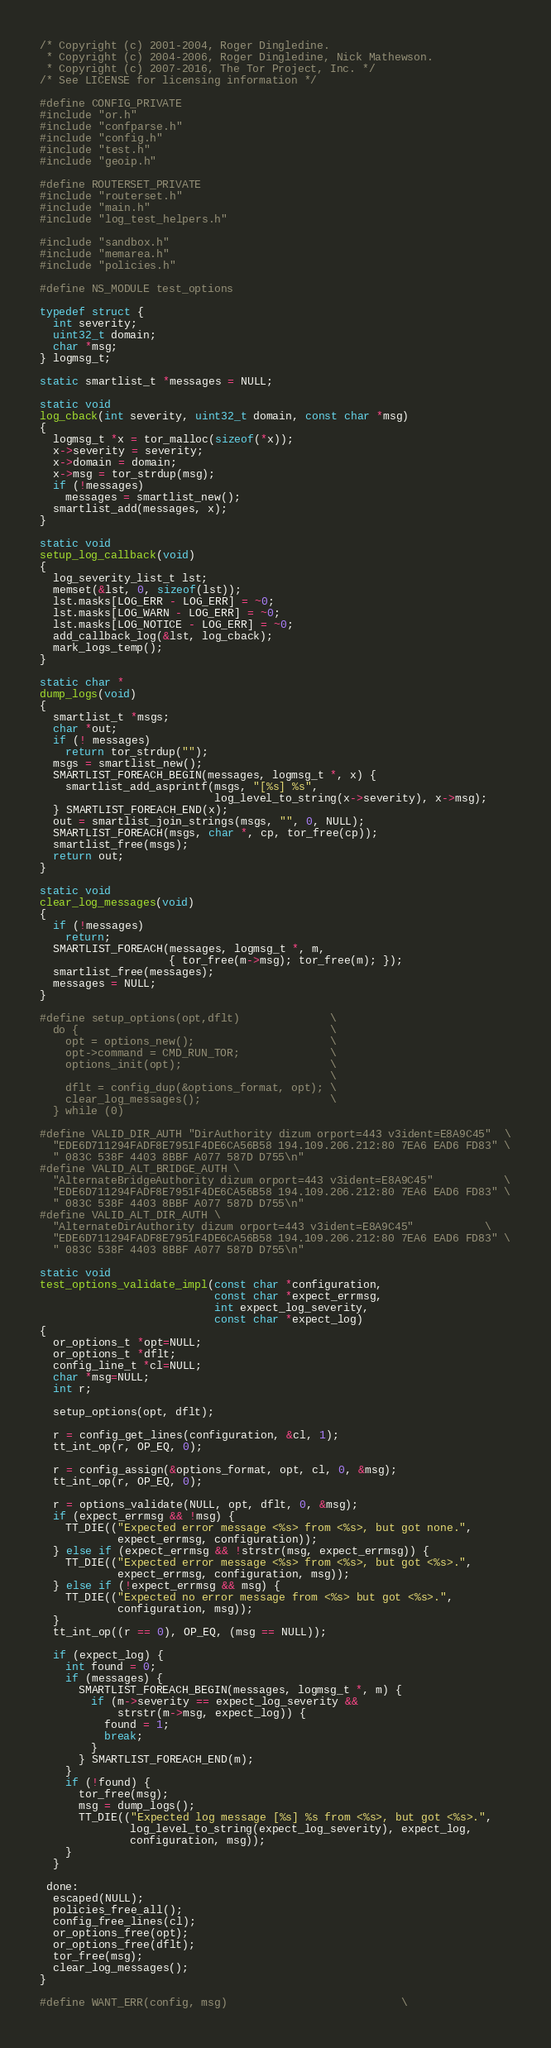Convert code to text. <code><loc_0><loc_0><loc_500><loc_500><_C_>/* Copyright (c) 2001-2004, Roger Dingledine.
 * Copyright (c) 2004-2006, Roger Dingledine, Nick Mathewson.
 * Copyright (c) 2007-2016, The Tor Project, Inc. */
/* See LICENSE for licensing information */

#define CONFIG_PRIVATE
#include "or.h"
#include "confparse.h"
#include "config.h"
#include "test.h"
#include "geoip.h"

#define ROUTERSET_PRIVATE
#include "routerset.h"
#include "main.h"
#include "log_test_helpers.h"

#include "sandbox.h"
#include "memarea.h"
#include "policies.h"

#define NS_MODULE test_options

typedef struct {
  int severity;
  uint32_t domain;
  char *msg;
} logmsg_t;

static smartlist_t *messages = NULL;

static void
log_cback(int severity, uint32_t domain, const char *msg)
{
  logmsg_t *x = tor_malloc(sizeof(*x));
  x->severity = severity;
  x->domain = domain;
  x->msg = tor_strdup(msg);
  if (!messages)
    messages = smartlist_new();
  smartlist_add(messages, x);
}

static void
setup_log_callback(void)
{
  log_severity_list_t lst;
  memset(&lst, 0, sizeof(lst));
  lst.masks[LOG_ERR - LOG_ERR] = ~0;
  lst.masks[LOG_WARN - LOG_ERR] = ~0;
  lst.masks[LOG_NOTICE - LOG_ERR] = ~0;
  add_callback_log(&lst, log_cback);
  mark_logs_temp();
}

static char *
dump_logs(void)
{
  smartlist_t *msgs;
  char *out;
  if (! messages)
    return tor_strdup("");
  msgs = smartlist_new();
  SMARTLIST_FOREACH_BEGIN(messages, logmsg_t *, x) {
    smartlist_add_asprintf(msgs, "[%s] %s",
                           log_level_to_string(x->severity), x->msg);
  } SMARTLIST_FOREACH_END(x);
  out = smartlist_join_strings(msgs, "", 0, NULL);
  SMARTLIST_FOREACH(msgs, char *, cp, tor_free(cp));
  smartlist_free(msgs);
  return out;
}

static void
clear_log_messages(void)
{
  if (!messages)
    return;
  SMARTLIST_FOREACH(messages, logmsg_t *, m,
                    { tor_free(m->msg); tor_free(m); });
  smartlist_free(messages);
  messages = NULL;
}

#define setup_options(opt,dflt)              \
  do {                                       \
    opt = options_new();                     \
    opt->command = CMD_RUN_TOR;              \
    options_init(opt);                       \
                                             \
    dflt = config_dup(&options_format, opt); \
    clear_log_messages();                    \
  } while (0)

#define VALID_DIR_AUTH "DirAuthority dizum orport=443 v3ident=E8A9C45"  \
  "EDE6D711294FADF8E7951F4DE6CA56B58 194.109.206.212:80 7EA6 EAD6 FD83" \
  " 083C 538F 4403 8BBF A077 587D D755\n"
#define VALID_ALT_BRIDGE_AUTH \
  "AlternateBridgeAuthority dizum orport=443 v3ident=E8A9C45"           \
  "EDE6D711294FADF8E7951F4DE6CA56B58 194.109.206.212:80 7EA6 EAD6 FD83" \
  " 083C 538F 4403 8BBF A077 587D D755\n"
#define VALID_ALT_DIR_AUTH \
  "AlternateDirAuthority dizum orport=443 v3ident=E8A9C45"           \
  "EDE6D711294FADF8E7951F4DE6CA56B58 194.109.206.212:80 7EA6 EAD6 FD83" \
  " 083C 538F 4403 8BBF A077 587D D755\n"

static void
test_options_validate_impl(const char *configuration,
                           const char *expect_errmsg,
                           int expect_log_severity,
                           const char *expect_log)
{
  or_options_t *opt=NULL;
  or_options_t *dflt;
  config_line_t *cl=NULL;
  char *msg=NULL;
  int r;

  setup_options(opt, dflt);

  r = config_get_lines(configuration, &cl, 1);
  tt_int_op(r, OP_EQ, 0);

  r = config_assign(&options_format, opt, cl, 0, &msg);
  tt_int_op(r, OP_EQ, 0);

  r = options_validate(NULL, opt, dflt, 0, &msg);
  if (expect_errmsg && !msg) {
    TT_DIE(("Expected error message <%s> from <%s>, but got none.",
            expect_errmsg, configuration));
  } else if (expect_errmsg && !strstr(msg, expect_errmsg)) {
    TT_DIE(("Expected error message <%s> from <%s>, but got <%s>.",
            expect_errmsg, configuration, msg));
  } else if (!expect_errmsg && msg) {
    TT_DIE(("Expected no error message from <%s> but got <%s>.",
            configuration, msg));
  }
  tt_int_op((r == 0), OP_EQ, (msg == NULL));

  if (expect_log) {
    int found = 0;
    if (messages) {
      SMARTLIST_FOREACH_BEGIN(messages, logmsg_t *, m) {
        if (m->severity == expect_log_severity &&
            strstr(m->msg, expect_log)) {
          found = 1;
          break;
        }
      } SMARTLIST_FOREACH_END(m);
    }
    if (!found) {
      tor_free(msg);
      msg = dump_logs();
      TT_DIE(("Expected log message [%s] %s from <%s>, but got <%s>.",
              log_level_to_string(expect_log_severity), expect_log,
              configuration, msg));
    }
  }

 done:
  escaped(NULL);
  policies_free_all();
  config_free_lines(cl);
  or_options_free(opt);
  or_options_free(dflt);
  tor_free(msg);
  clear_log_messages();
}

#define WANT_ERR(config, msg)                           \</code> 